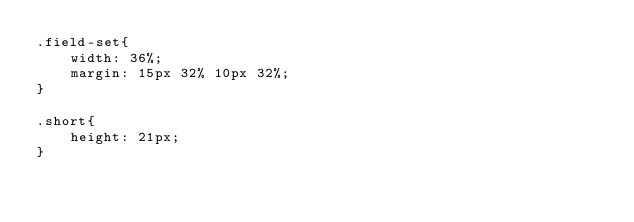<code> <loc_0><loc_0><loc_500><loc_500><_CSS_>.field-set{
    width: 36%;
    margin: 15px 32% 10px 32%;
}

.short{
    height: 21px;
}</code> 